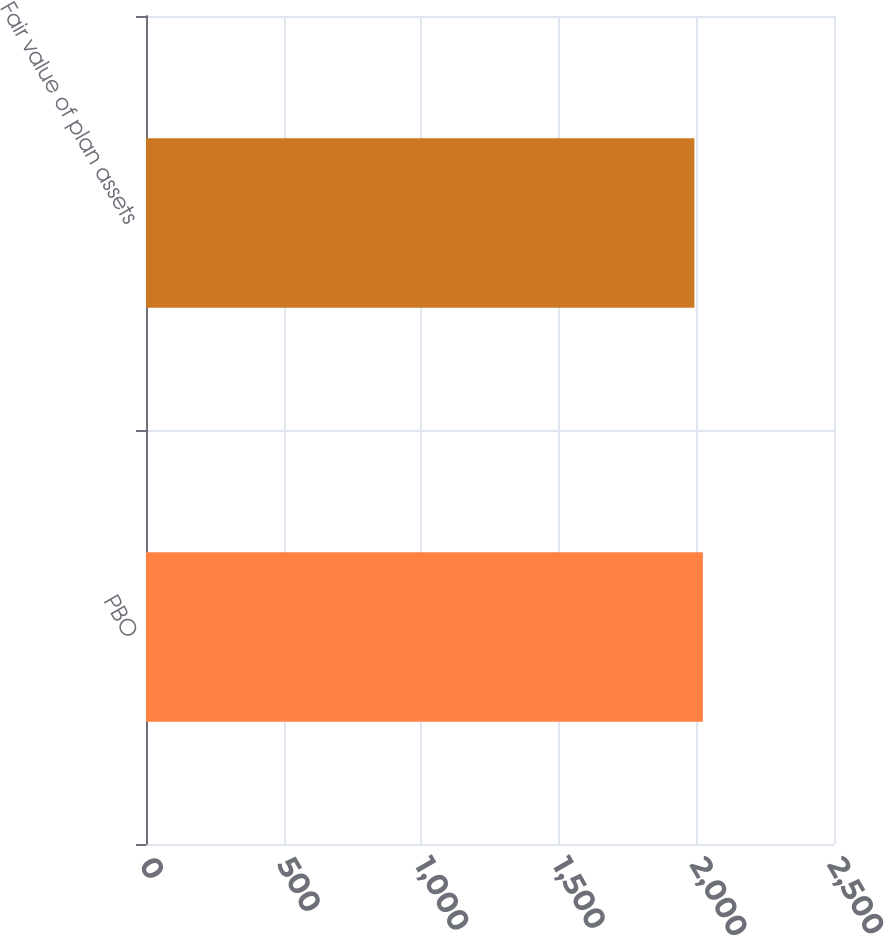Convert chart to OTSL. <chart><loc_0><loc_0><loc_500><loc_500><bar_chart><fcel>PBO<fcel>Fair value of plan assets<nl><fcel>2023.4<fcel>1992.6<nl></chart> 